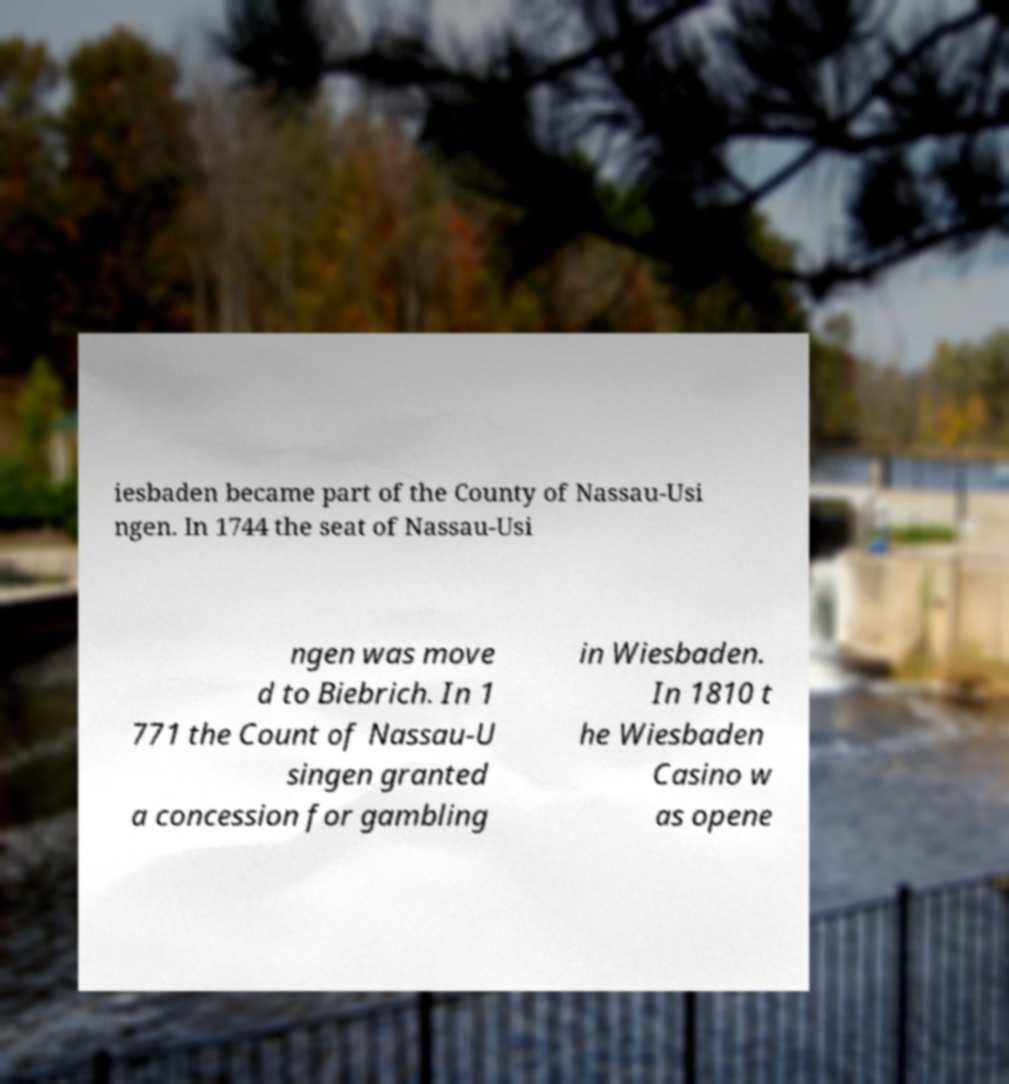For documentation purposes, I need the text within this image transcribed. Could you provide that? iesbaden became part of the County of Nassau-Usi ngen. In 1744 the seat of Nassau-Usi ngen was move d to Biebrich. In 1 771 the Count of Nassau-U singen granted a concession for gambling in Wiesbaden. In 1810 t he Wiesbaden Casino w as opene 